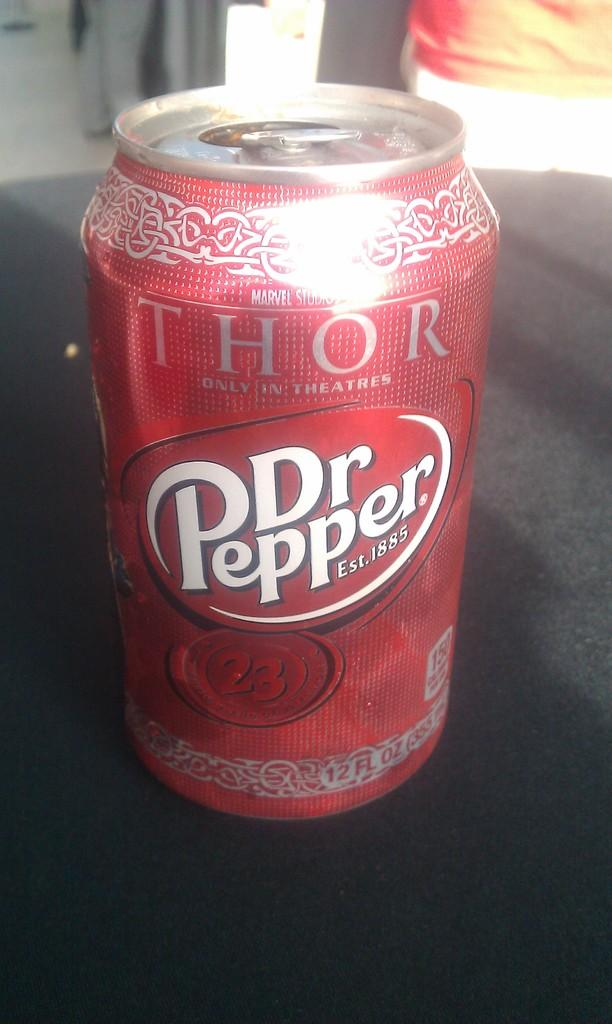<image>
Provide a brief description of the given image. Dr. Pepper can with advertising on Thor and Marvel studios. 